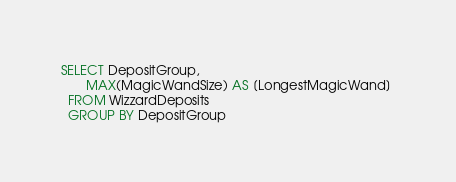<code> <loc_0><loc_0><loc_500><loc_500><_SQL_>SELECT DepositGroup,
	   MAX(MagicWandSize) AS [LongestMagicWand] 
  FROM WizzardDeposits
  GROUP BY DepositGroup</code> 